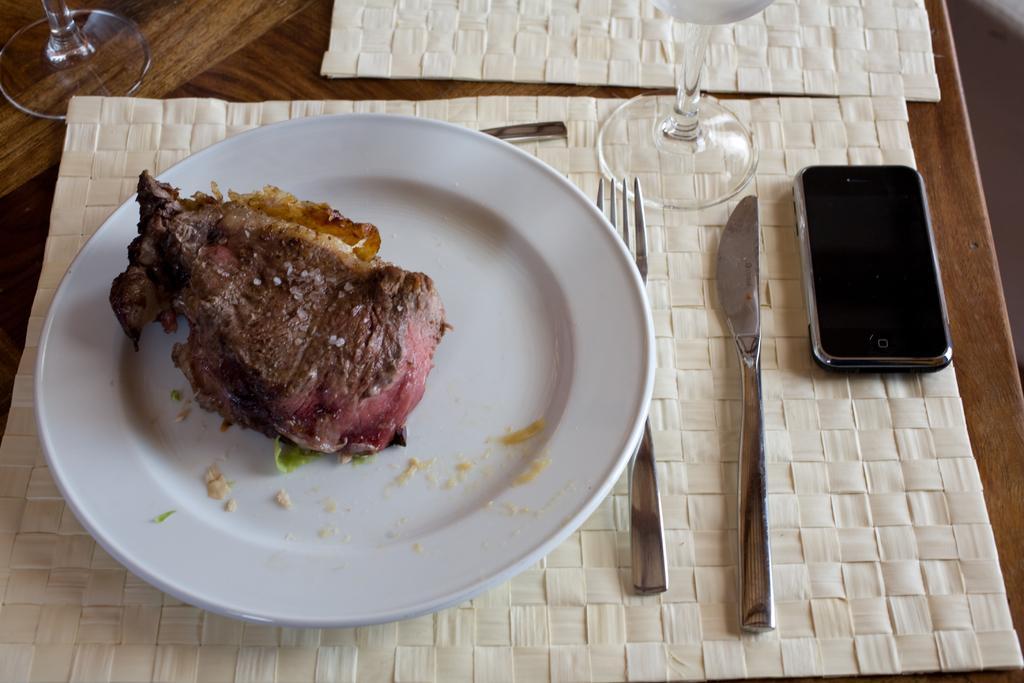Can you describe this image briefly? This picture contain a table on which plate containing food, fork, knife, glass and mobile phone are placed. 